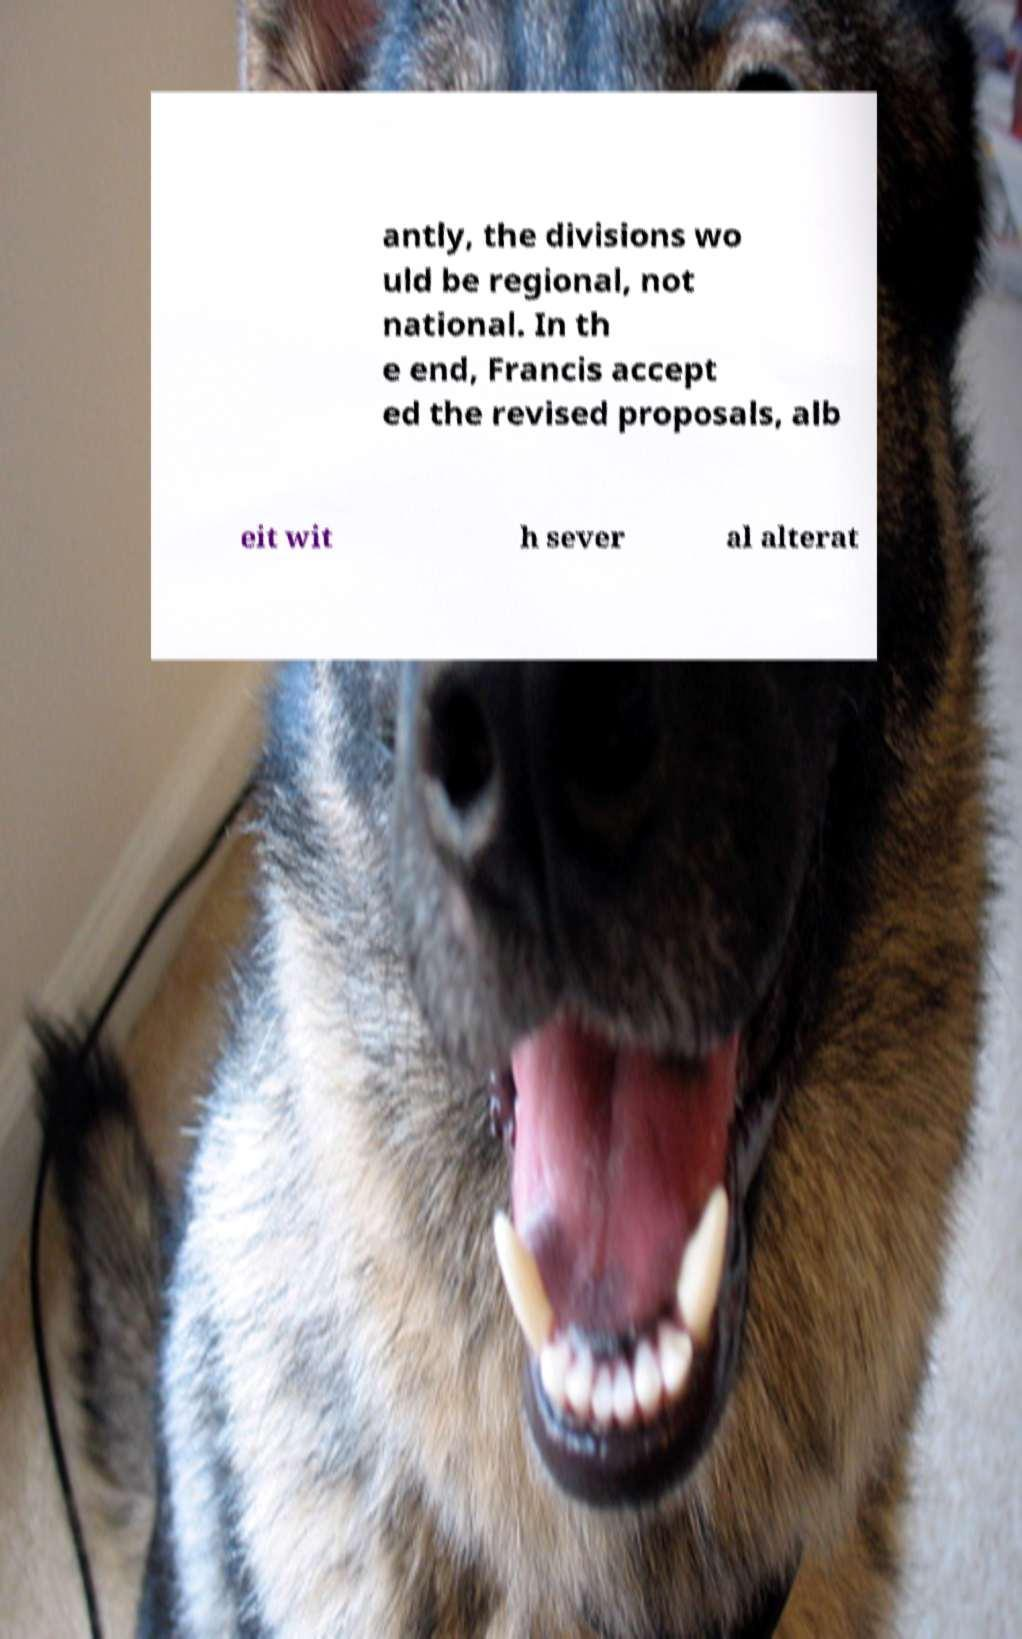Can you read and provide the text displayed in the image?This photo seems to have some interesting text. Can you extract and type it out for me? antly, the divisions wo uld be regional, not national. In th e end, Francis accept ed the revised proposals, alb eit wit h sever al alterat 